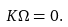Convert formula to latex. <formula><loc_0><loc_0><loc_500><loc_500>K \Omega = 0 .</formula> 